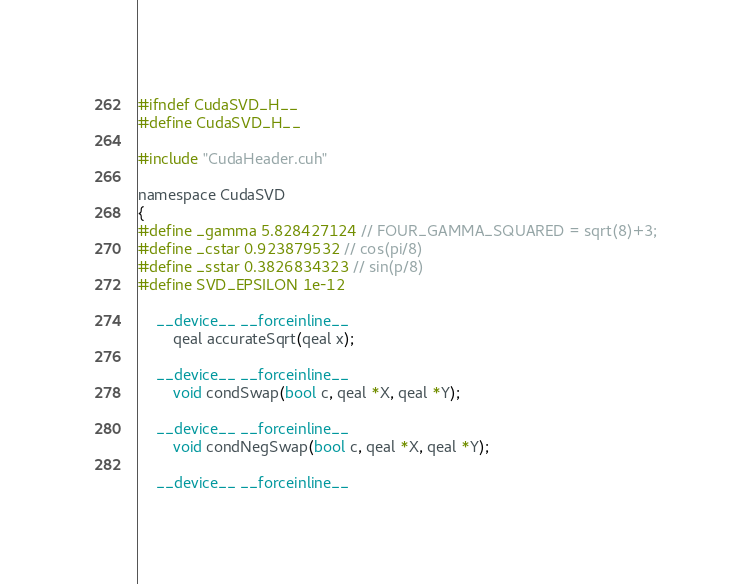<code> <loc_0><loc_0><loc_500><loc_500><_Cuda_>#ifndef CudaSVD_H__
#define CudaSVD_H__

#include "CudaHeader.cuh"

namespace CudaSVD
{
#define _gamma 5.828427124 // FOUR_GAMMA_SQUARED = sqrt(8)+3;
#define _cstar 0.923879532 // cos(pi/8)
#define _sstar 0.3826834323 // sin(p/8)
#define SVD_EPSILON 1e-12

	__device__ __forceinline__
		qeal accurateSqrt(qeal x);

	__device__ __forceinline__
		void condSwap(bool c, qeal *X, qeal *Y);

	__device__ __forceinline__
		void condNegSwap(bool c, qeal *X, qeal *Y);

	__device__ __forceinline__</code> 